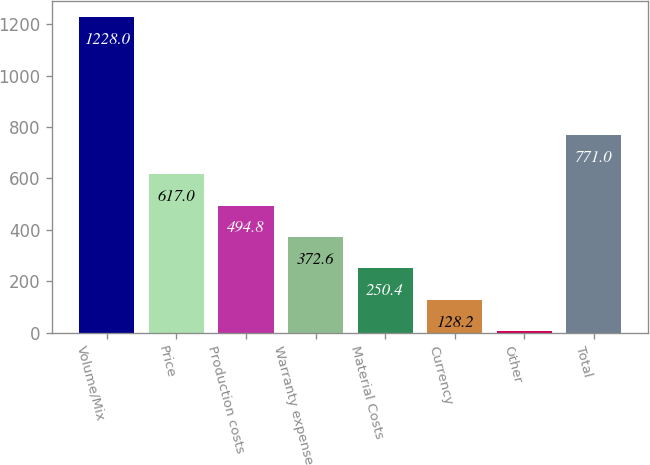<chart> <loc_0><loc_0><loc_500><loc_500><bar_chart><fcel>Volume/Mix<fcel>Price<fcel>Production costs<fcel>Warranty expense<fcel>Material Costs<fcel>Currency<fcel>Other<fcel>Total<nl><fcel>1228<fcel>617<fcel>494.8<fcel>372.6<fcel>250.4<fcel>128.2<fcel>6<fcel>771<nl></chart> 